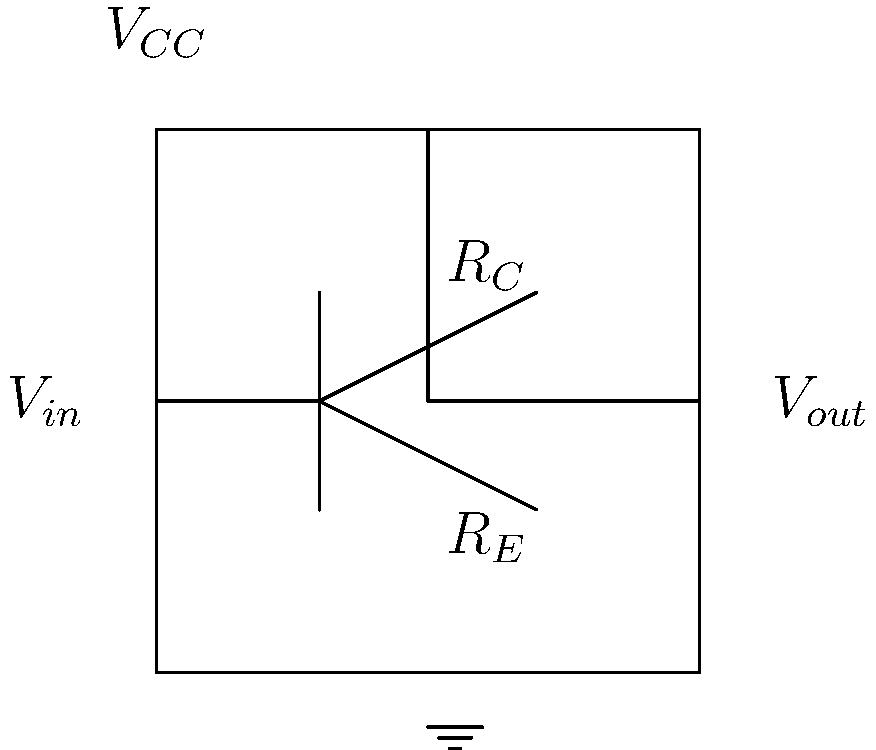Given the common-emitter amplifier circuit shown above, what is the approximate voltage gain $A_v$ of this amplifier in terms of $R_C$ and $R_E$? To determine the voltage gain of a common-emitter amplifier, we can follow these steps:

1. In a common-emitter configuration, the voltage gain is primarily determined by the ratio of the collector resistance ($R_C$) to the emitter resistance ($R_E$).

2. The general formula for voltage gain in a common-emitter amplifier is:

   $$A_v = -\frac{R_C}{R_E}$$

3. The negative sign indicates a 180-degree phase shift between input and output signals.

4. This approximation assumes:
   a) The transistor's current gain (β) is large
   b) The emitter bypass capacitor (if present) effectively shorts AC signals around $R_E$
   c) We're operating in the mid-frequency range where capacitive effects are negligible

5. In practice, the actual gain might be slightly less due to other factors like transistor parameters and load effects, but this formula provides a good approximation for quick calculations.

6. For more precise calculations, you would need to consider additional factors such as the transistor's transconductance and output resistance, but these are often negligible in first-order approximations.
Answer: $A_v \approx -\frac{R_C}{R_E}$ 